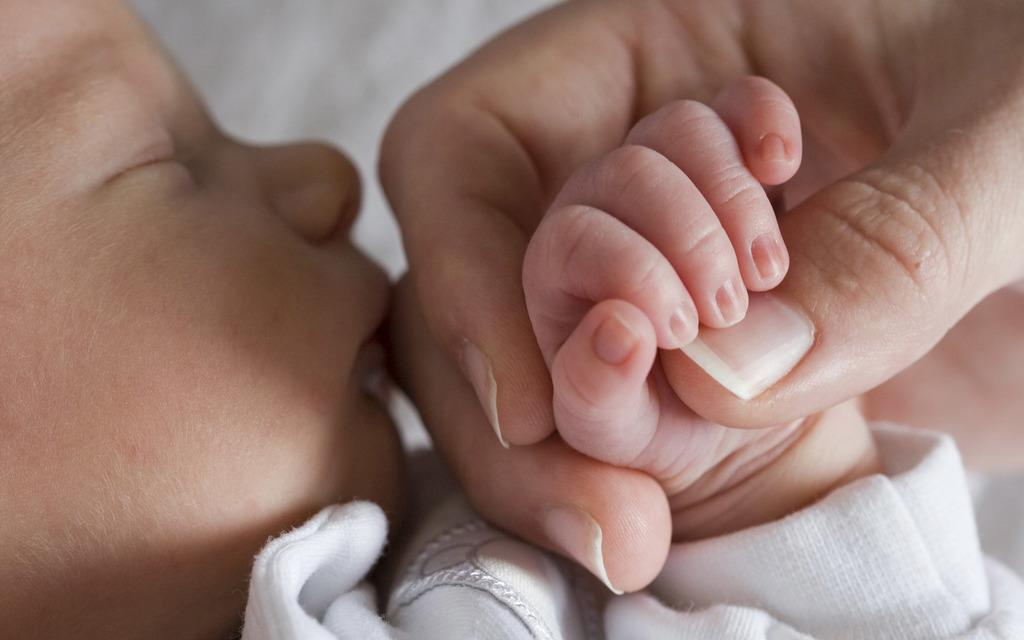What is the main subject of the image? The main subject of the image is a sleeping baby. What is the baby wearing in the image? The baby is wearing a white dress in the image. Can you describe the interaction between the baby and another person in the image? A person's hand is holding the baby's hand in the image. What type of vacation is the baby planning to go on, as seen in the image? There is no indication of a vacation in the image; it simply shows a sleeping baby with a person's hand holding their hand. 